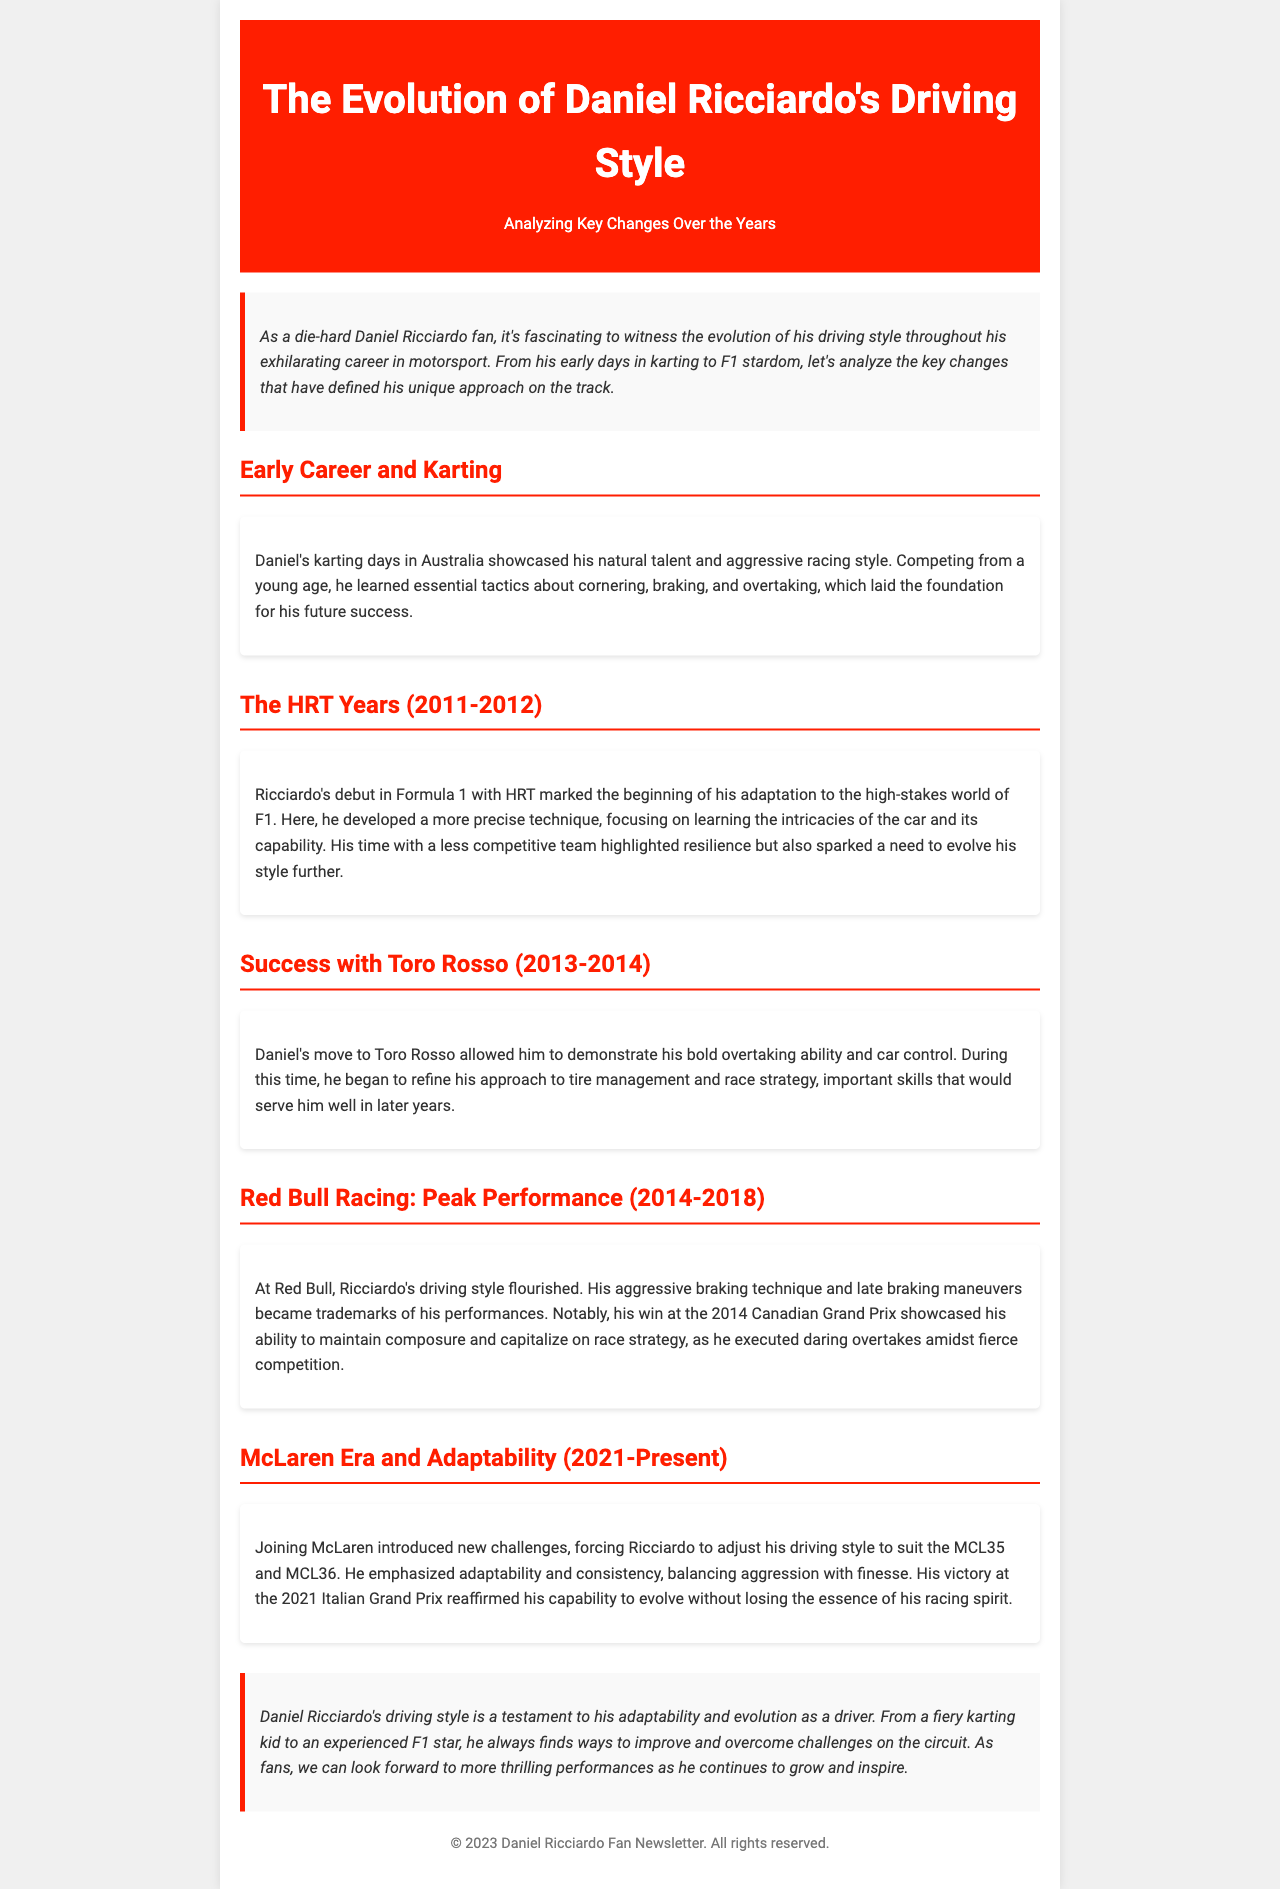What was Daniel Ricciardo's debut year in Formula 1? The document mentions that Ricciardo debuted in Formula 1 with HRT in 2011.
Answer: 2011 Which team did Daniel Ricciardo race for between 2014 and 2018? The section titled "Red Bull Racing: Peak Performance" indicates that he raced for Red Bull during these years.
Answer: Red Bull Racing What notable victory did Ricciardo achieve at the 2021 Italian Grand Prix? The document highlights that Ricciardo won at the 2021 Italian Grand Prix, showcasing his capabilities in the McLaren era.
Answer: Victory What driving technique became a trademark of Ricciardo during his time at Red Bull? The document states that his aggressive braking technique and late braking maneuvers became trademarks of his performances at Red Bull.
Answer: Aggressive braking What period does the McLaren era cover in Ricciardo's career? The document explicitly mentions that the McLaren era spans from 2021 to the present.
Answer: 2021-Present How did Ricciardo's driving style change during his HRT years? The section discusses how he developed a more precise technique focusing on the intricacies of the car.
Answer: More precise technique What is considered a key skill that Ricciardo refined while with Toro Rosso? The document notes that he began to refine his approach to tire management and race strategy during his time with Toro Rosso.
Answer: Tire management What is the overall theme of the document regarding Ricciardo's driving style? The conclusion summarizes that Ricciardo's driving style reflects his adaptability and evolution as a driver throughout his career.
Answer: Adaptability 